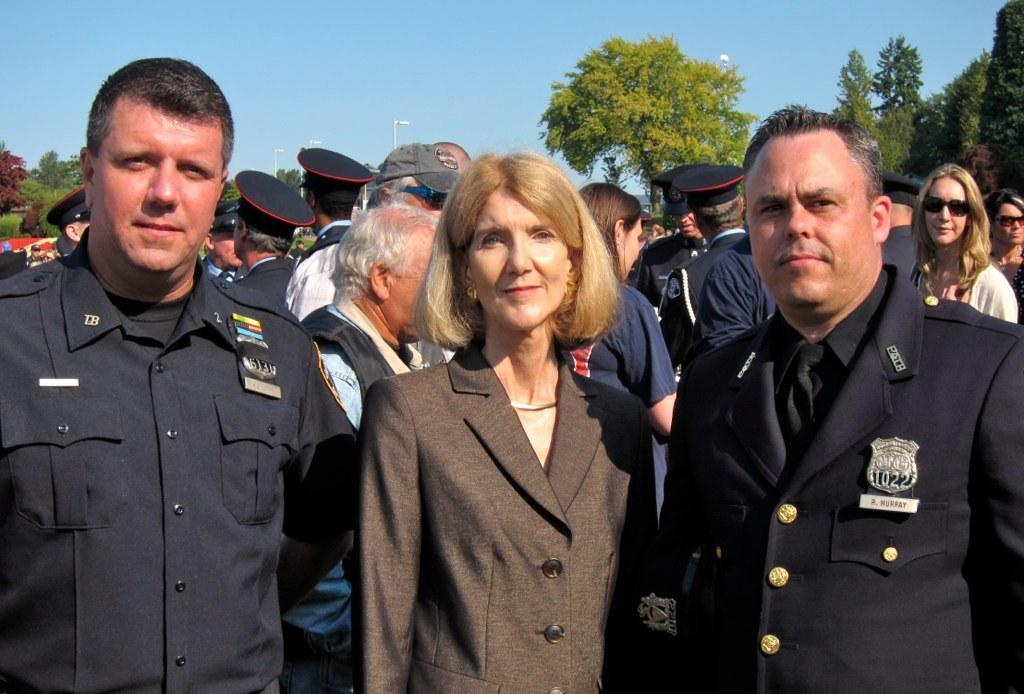What is the main subject of the image? The main subject of the image is a group of people. Can you describe the attire of some of the people in the image? Some of the people in the image are wearing uniforms. What can be seen in the background of the image? There are trees visible in the background of the image. What type of jelly can be seen in the image? There is no jelly present in the image. How many carriages are visible in the image? There are no carriages present in the image. 